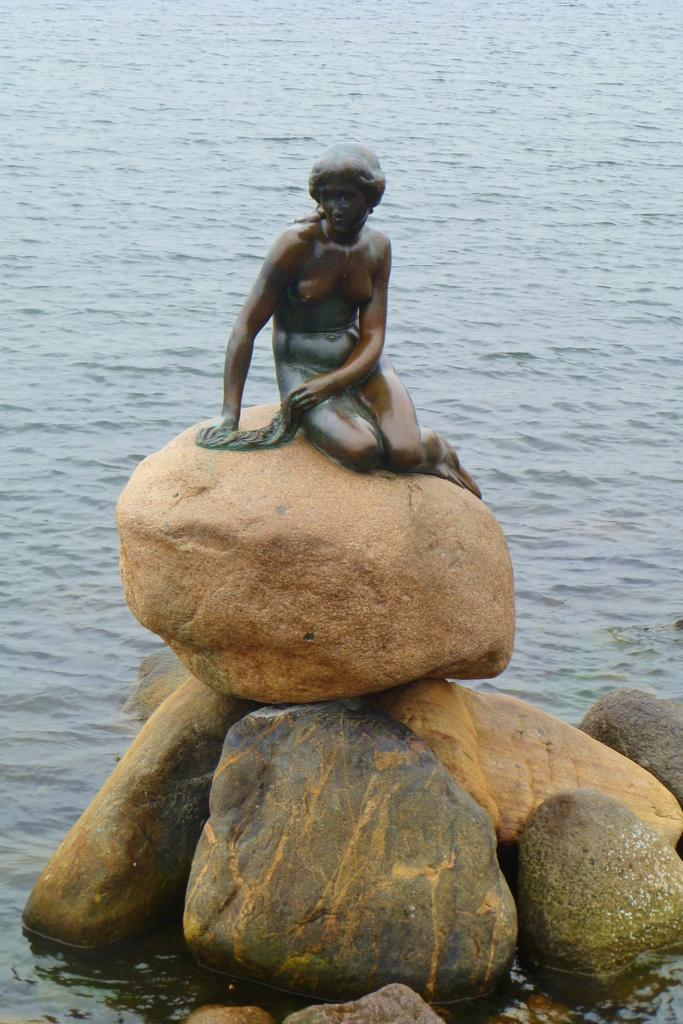What is the main subject in the center of the image? There is a statue in the center of the image. What is the statue standing on? The statue is on stones. What can be seen in the background of the image? There is water visible in the background of the image. What type of hat is the beetle wearing in the image? There is no beetle or hat present in the image. Can you describe the squirrel's interaction with the statue in the image? There is no squirrel present in the image, so it cannot be interacting with the statue. 